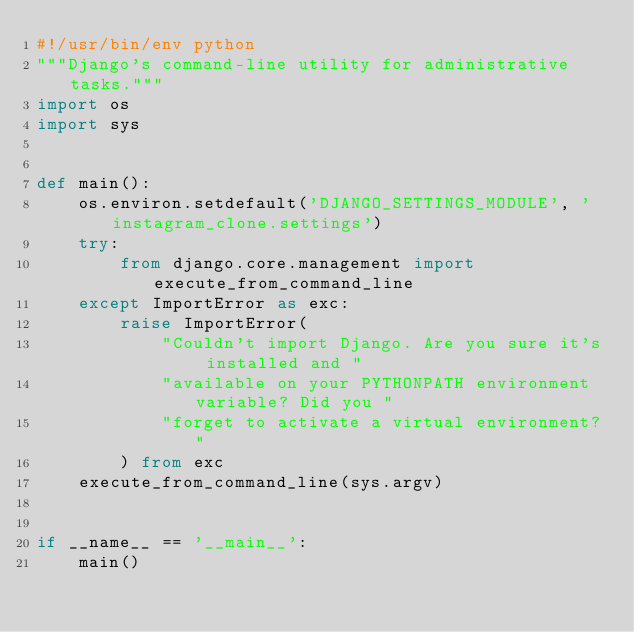Convert code to text. <code><loc_0><loc_0><loc_500><loc_500><_Python_>#!/usr/bin/env python
"""Django's command-line utility for administrative tasks."""
import os
import sys


def main():
    os.environ.setdefault('DJANGO_SETTINGS_MODULE', 'instagram_clone.settings')
    try:
        from django.core.management import execute_from_command_line
    except ImportError as exc:
        raise ImportError(
            "Couldn't import Django. Are you sure it's installed and "
            "available on your PYTHONPATH environment variable? Did you "
            "forget to activate a virtual environment?"
        ) from exc
    execute_from_command_line(sys.argv)


if __name__ == '__main__':
    main()
</code> 